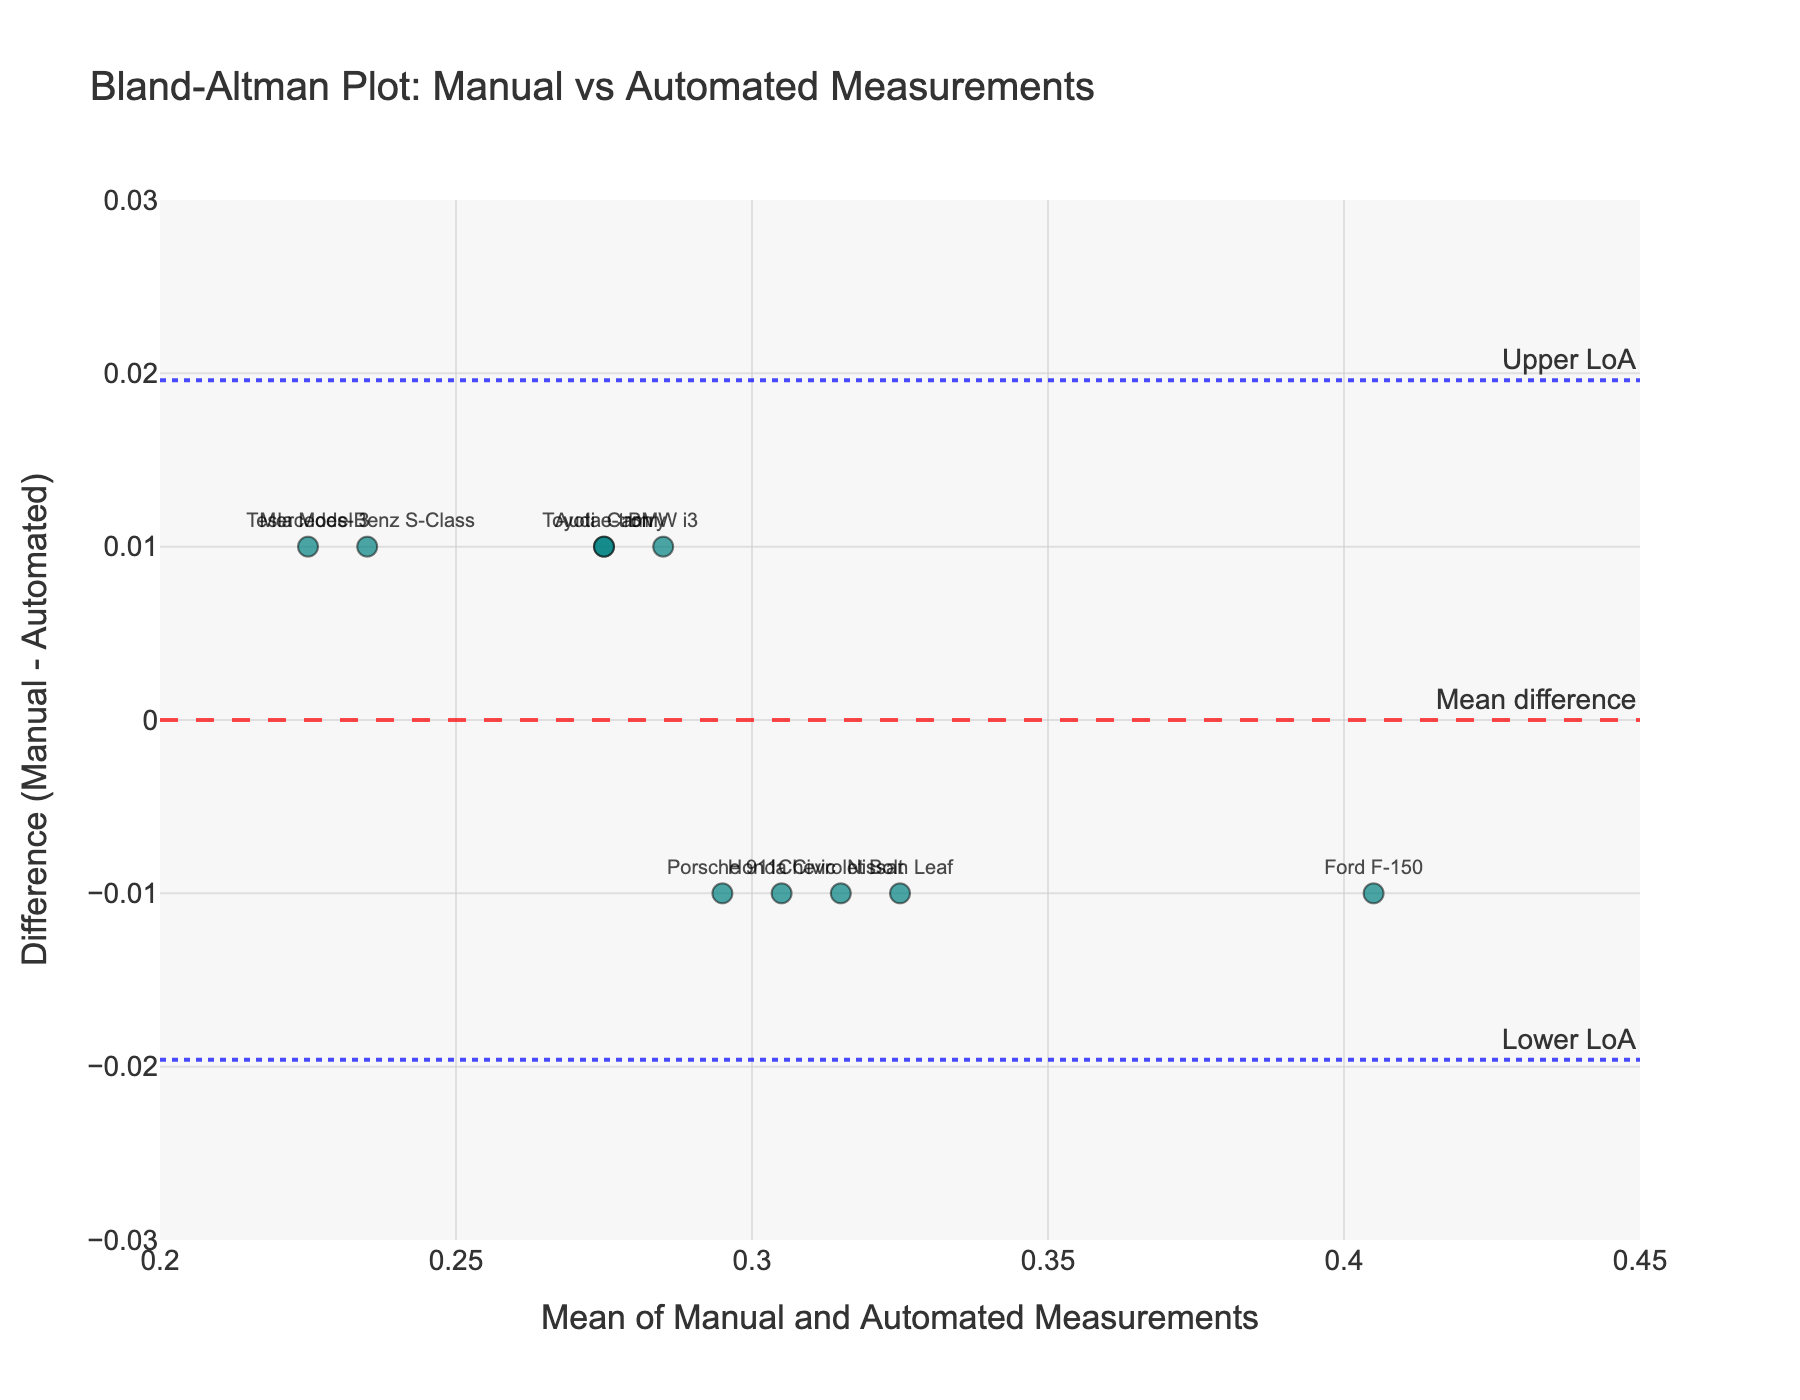What is the title of the plot? The title is located at the top of the plot and provides a summary of what the plot is about. It reads "Bland-Altman Plot: Manual vs Automated Measurements".
Answer: Bland-Altman Plot: Manual vs Automated Measurements How many data points are there in the plot? The number of data points corresponds to the number of vehicle models listed in the data. Each model represents one point on the plot. There are 10 vehicle models.
Answer: 10 What is the color of the data points in the plot? The color of the data points can be observed visually. All the data points are colored in a shade of teal.
Answer: Teal What is the mean difference between manual and automated measurements? The mean difference is marked by a dashed line across the plot, and it has an annotation. The annotation reads "Mean difference". The value of this line is 0.00.
Answer: 0.00 What is the upper limit of agreement (Upper LoA)? The upper limit of agreement is indicated by a dotted blue line with an annotation "Upper LoA". By finding this line on the y-axis, we see the value is approximately 0.0294.
Answer: 0.0294 Which vehicle model has the highest difference between manual and automated measurements? Observing the y-axis, we identify the data point with the highest position above the mean line. The text label on this point indicates "Nissan Leaf".
Answer: Nissan Leaf What is the manual measurement for the Tesla Model 3? Although the plot does not provide specific values for individual measurements, it does display differences and mean values. For this specific value, refer to the raw data provided. The manual measurement for the Tesla Model 3 is 0.23.
Answer: 0.23 Which vehicle model has the lowest average between manual and automated measurements? By inspecting the x-axis (mean values), we look for the data point furthest to the left. The text label indicates it is "Mercedes-Benz S-Class".
Answer: Mercedes-Benz S-Class Is there any data point located below the lower limit of agreement (Lower LoA)? We can check the dotted blue line labeled "Lower LoA" and see if any data points fall below this line. The lower LoA line is at approximately -0.0294, and no points are below this.
Answer: No Between which range are the mean values of the measurements? Observing the x-axis values, the range of mean values spans from the lowest to the highest labeled point. The x-axis starts at 0.2 and extends to 0.45.
Answer: 0.2 to 0.45 